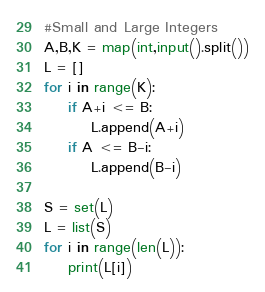Convert code to text. <code><loc_0><loc_0><loc_500><loc_500><_Python_>#Small and Large Integers
A,B,K = map(int,input().split())
L = []
for i in range(K):
    if A+i <= B: 
        L.append(A+i)
    if A <= B-i:
        L.append(B-i)

S = set(L)
L = list(S)
for i in range(len(L)):
    print(L[i])</code> 